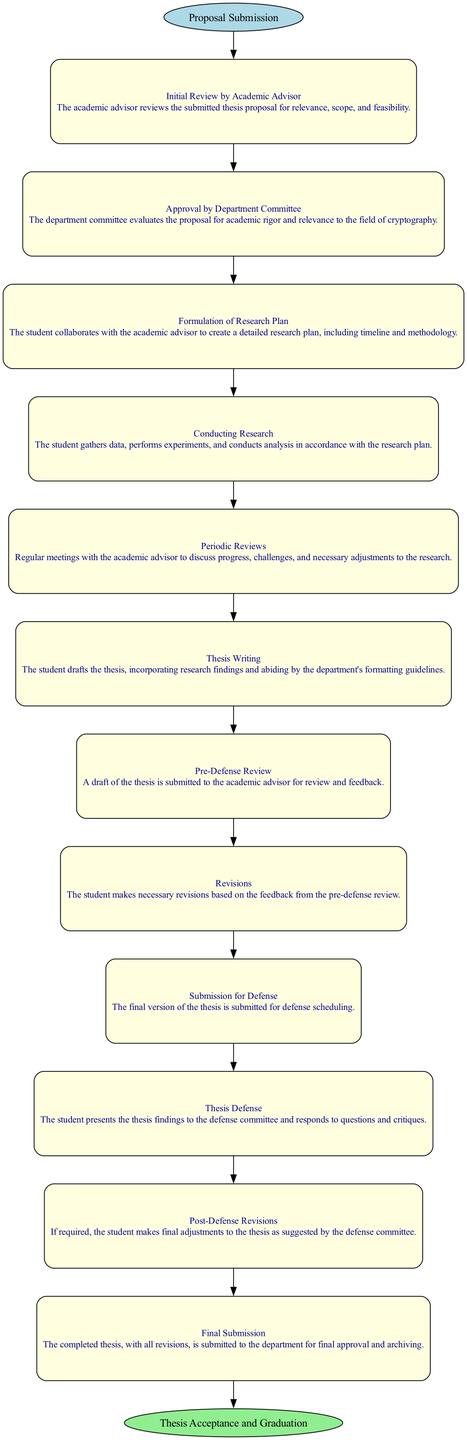What is the starting event in the thesis evaluation process? The starting event, as indicated in the diagram, is "Proposal Submission." This is typically the initial action taken by students in the process.
Answer: Proposal Submission How many activities are listed in the thesis evaluation process? By counting the activities provided in the diagram, there are a total of 12 activities, beginning from the initial review to final submission.
Answer: 12 What follows the "Thesis Writing" activity? The activity that follows "Thesis Writing" is "Pre-Defense Review," where the student submits a draft to the academic advisor for feedback.
Answer: Pre-Defense Review Which activity requires collaboration with the academic advisor? The "Formulation of Research Plan" requires collaboration with the academic advisor, as it involves creating a detailed research plan.
Answer: Formulation of Research Plan What is the last activity before the final submission? The last activity before the final submission is "Post-Defense Revisions," where the student makes adjustments if required after the defense.
Answer: Post-Defense Revisions What is the final outcome of the student thesis evaluation process? The final outcome, as depicted in the ending event of the diagram, is "Thesis Acceptance and Graduation," indicating the successful completion of the process.
Answer: Thesis Acceptance and Graduation How many edges are there between the activities? There are 11 edges connecting the 12 activities in a sequential manner, as each activity leads to the next to complete the process.
Answer: 11 Which activity leads directly to the "Thesis Defense"? The activity that leads directly to "Thesis Defense" is "Submission for Defense," where the final version of the thesis is submitted for scheduling.
Answer: Submission for Defense What activity comes immediately before the "Revisions" activity? The activity that comes immediately before "Revisions" is "Pre-Defense Review," where feedback is provided on the thesis draft.
Answer: Pre-Defense Review 